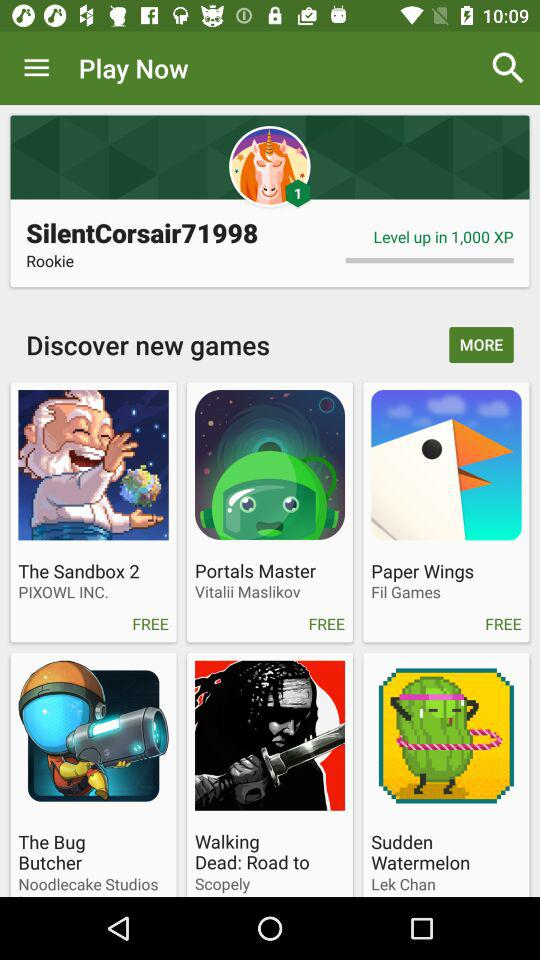What is the level? The level is 1. 